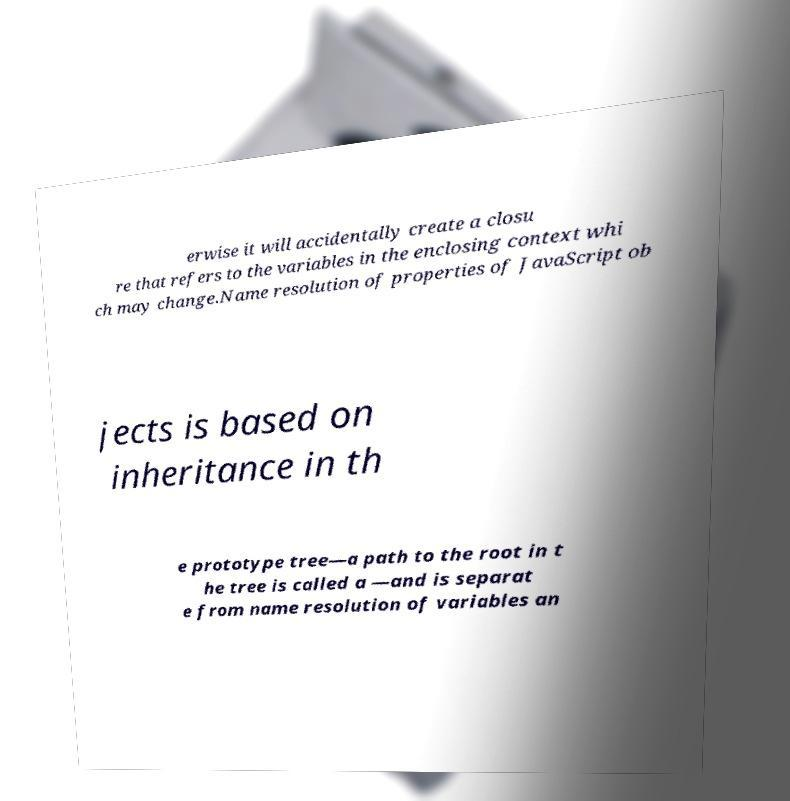I need the written content from this picture converted into text. Can you do that? erwise it will accidentally create a closu re that refers to the variables in the enclosing context whi ch may change.Name resolution of properties of JavaScript ob jects is based on inheritance in th e prototype tree—a path to the root in t he tree is called a —and is separat e from name resolution of variables an 